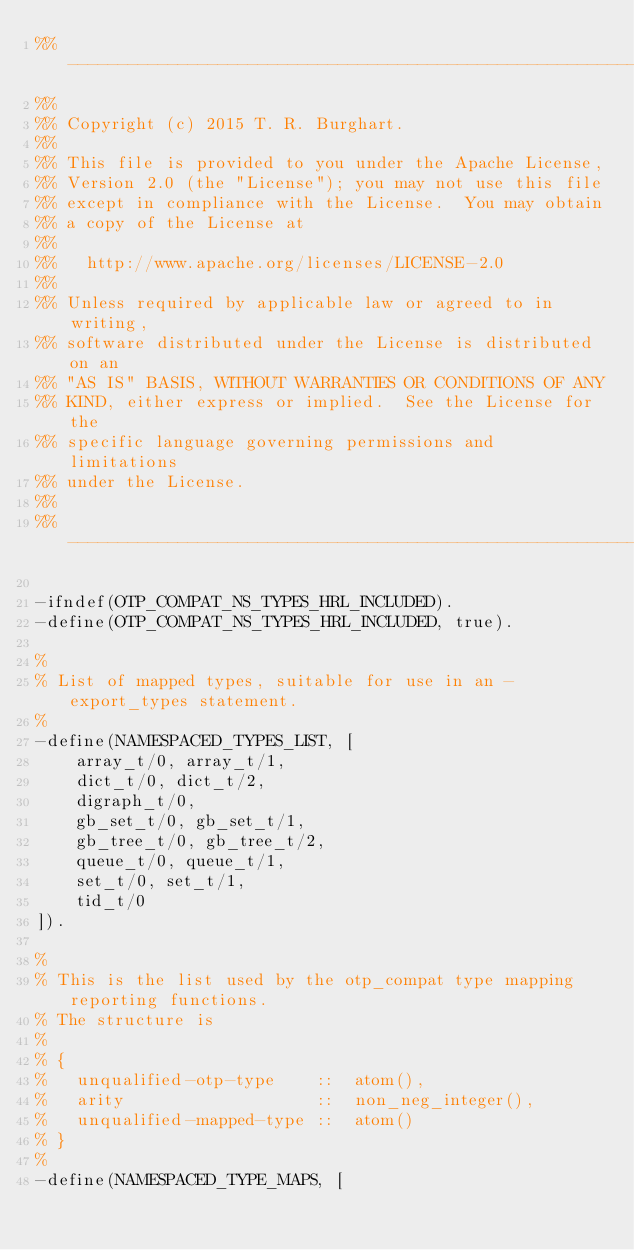Convert code to text. <code><loc_0><loc_0><loc_500><loc_500><_Erlang_>%% -------------------------------------------------------------------
%%
%% Copyright (c) 2015 T. R. Burghart.
%%
%% This file is provided to you under the Apache License,
%% Version 2.0 (the "License"); you may not use this file
%% except in compliance with the License.  You may obtain
%% a copy of the License at
%%
%%   http://www.apache.org/licenses/LICENSE-2.0
%%
%% Unless required by applicable law or agreed to in writing,
%% software distributed under the License is distributed on an
%% "AS IS" BASIS, WITHOUT WARRANTIES OR CONDITIONS OF ANY
%% KIND, either express or implied.  See the License for the
%% specific language governing permissions and limitations
%% under the License.
%%
%% -------------------------------------------------------------------

-ifndef(OTP_COMPAT_NS_TYPES_HRL_INCLUDED).
-define(OTP_COMPAT_NS_TYPES_HRL_INCLUDED, true).

%
% List of mapped types, suitable for use in an -export_types statement.
%
-define(NAMESPACED_TYPES_LIST, [
    array_t/0, array_t/1,
    dict_t/0, dict_t/2,
    digraph_t/0,
    gb_set_t/0, gb_set_t/1,
    gb_tree_t/0, gb_tree_t/2,
    queue_t/0, queue_t/1,
    set_t/0, set_t/1,
    tid_t/0
]).

%
% This is the list used by the otp_compat type mapping reporting functions.
% The structure is
%
% {
%   unqualified-otp-type    ::  atom(),
%   arity                   ::  non_neg_integer(),
%   unqualified-mapped-type ::  atom()
% }
%
-define(NAMESPACED_TYPE_MAPS, [</code> 